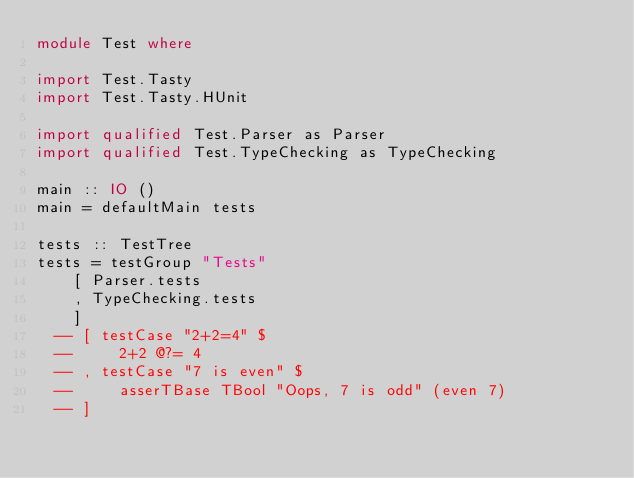Convert code to text. <code><loc_0><loc_0><loc_500><loc_500><_Haskell_>module Test where

import Test.Tasty
import Test.Tasty.HUnit

import qualified Test.Parser as Parser
import qualified Test.TypeChecking as TypeChecking

main :: IO ()
main = defaultMain tests

tests :: TestTree
tests = testGroup "Tests"
    [ Parser.tests
    , TypeChecking.tests
    ]
  -- [ testCase "2+2=4" $
  --     2+2 @?= 4
  -- , testCase "7 is even" $
  --     asserTBase TBool "Oops, 7 is odd" (even 7)
  -- ]
</code> 